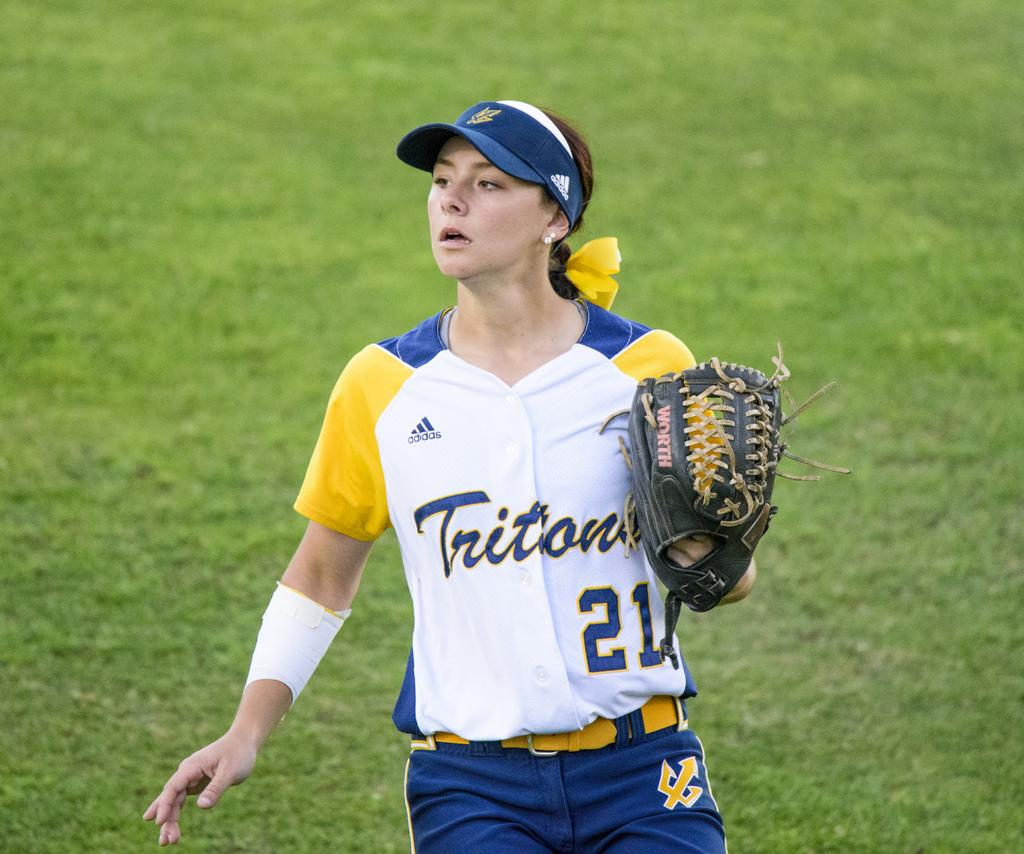<image>
Describe the image concisely. A woman with a baseball mitt wearing a Tritons 21 jersey. 